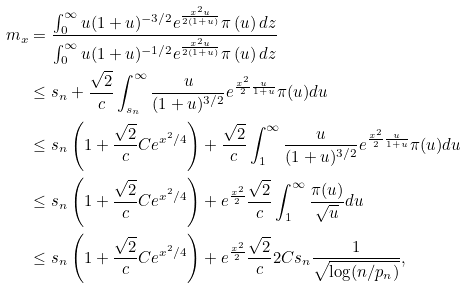<formula> <loc_0><loc_0><loc_500><loc_500>m _ { x } & = \frac { \int _ { 0 } ^ { \infty } u ( 1 + u ) ^ { - 3 / 2 } e ^ { \frac { x ^ { 2 } u } { 2 ( 1 + u ) } } \pi \left ( u \right ) d z } { \int _ { 0 } ^ { \infty } u ( 1 + u ) ^ { - 1 / 2 } e ^ { \frac { x ^ { 2 } u } { 2 ( 1 + u ) } } \pi \left ( u \right ) d z } \\ & \leq s _ { n } + \frac { \sqrt { 2 } } { c } \int _ { s _ { n } } ^ { \infty } \frac { u } { ( 1 + u ) ^ { 3 / 2 } } e ^ { \frac { x ^ { 2 } } { 2 } \frac { u } { 1 + u } } \pi ( u ) d u \\ & \leq s _ { n } \left ( 1 + \frac { \sqrt { 2 } } { c } C e ^ { x ^ { 2 } / 4 } \right ) + \frac { \sqrt { 2 } } { c } \int _ { 1 } ^ { \infty } \frac { u } { ( 1 + u ) ^ { 3 / 2 } } e ^ { \frac { x ^ { 2 } } { 2 } \frac { u } { 1 + u } } \pi ( u ) d u \\ & \leq s _ { n } \left ( 1 + \frac { \sqrt { 2 } } { c } C e ^ { x ^ { 2 } / 4 } \right ) + e ^ { \frac { x ^ { 2 } } { 2 } } \frac { \sqrt { 2 } } { c } \int _ { 1 } ^ { \infty } \frac { \pi ( u ) } { \sqrt { u } } d u \\ & \leq s _ { n } \left ( 1 + \frac { \sqrt { 2 } } { c } C e ^ { x ^ { 2 } / 4 } \right ) + e ^ { \frac { x ^ { 2 } } { 2 } } \frac { \sqrt { 2 } } { c } 2 C s _ { n } \frac { 1 } { \sqrt { \log ( n / p _ { n } ) } } ,</formula> 